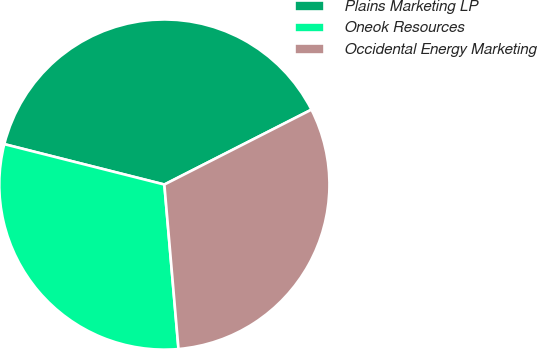Convert chart to OTSL. <chart><loc_0><loc_0><loc_500><loc_500><pie_chart><fcel>Plains Marketing LP<fcel>Oneok Resources<fcel>Occidental Energy Marketing<nl><fcel>38.57%<fcel>30.3%<fcel>31.13%<nl></chart> 